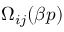<formula> <loc_0><loc_0><loc_500><loc_500>\Omega _ { i j } ( \beta p )</formula> 